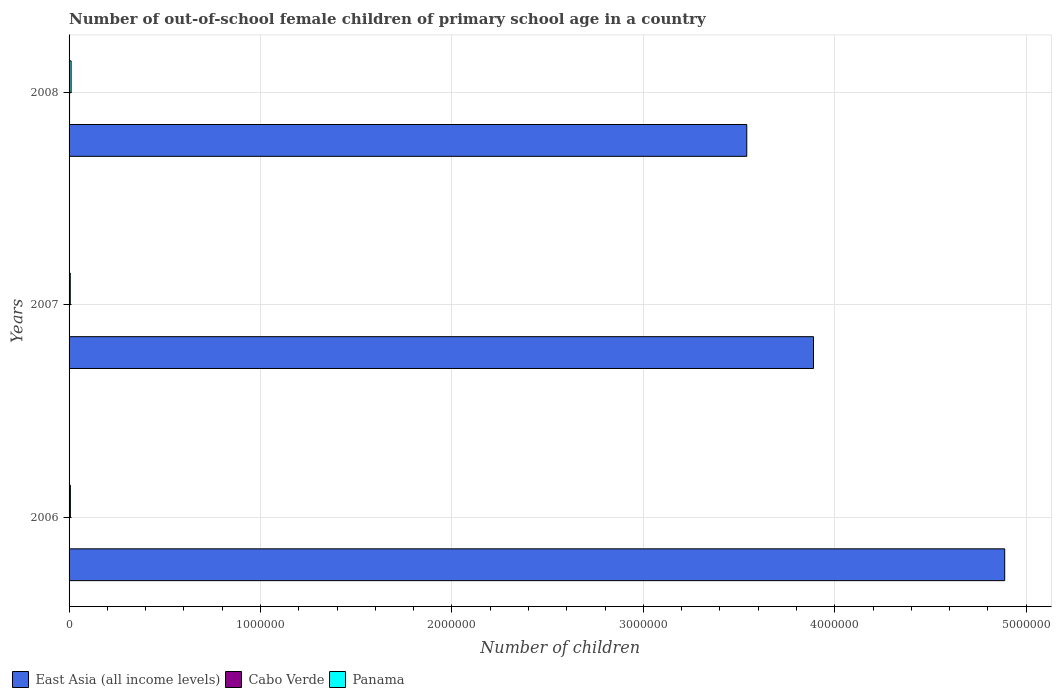How many different coloured bars are there?
Give a very brief answer. 3. Are the number of bars on each tick of the Y-axis equal?
Provide a short and direct response. Yes. How many bars are there on the 2nd tick from the top?
Keep it short and to the point. 3. How many bars are there on the 3rd tick from the bottom?
Provide a short and direct response. 3. What is the label of the 3rd group of bars from the top?
Give a very brief answer. 2006. In how many cases, is the number of bars for a given year not equal to the number of legend labels?
Keep it short and to the point. 0. What is the number of out-of-school female children in East Asia (all income levels) in 2007?
Your response must be concise. 3.89e+06. Across all years, what is the maximum number of out-of-school female children in Panama?
Give a very brief answer. 1.06e+04. Across all years, what is the minimum number of out-of-school female children in East Asia (all income levels)?
Keep it short and to the point. 3.54e+06. In which year was the number of out-of-school female children in East Asia (all income levels) maximum?
Provide a short and direct response. 2006. In which year was the number of out-of-school female children in East Asia (all income levels) minimum?
Provide a succinct answer. 2008. What is the total number of out-of-school female children in Panama in the graph?
Make the answer very short. 2.37e+04. What is the difference between the number of out-of-school female children in Panama in 2006 and that in 2007?
Offer a very short reply. 536. What is the difference between the number of out-of-school female children in Panama in 2008 and the number of out-of-school female children in East Asia (all income levels) in 2007?
Your response must be concise. -3.88e+06. What is the average number of out-of-school female children in Cabo Verde per year?
Provide a short and direct response. 2289. In the year 2006, what is the difference between the number of out-of-school female children in Cabo Verde and number of out-of-school female children in East Asia (all income levels)?
Keep it short and to the point. -4.89e+06. In how many years, is the number of out-of-school female children in Cabo Verde greater than 600000 ?
Keep it short and to the point. 0. What is the ratio of the number of out-of-school female children in Cabo Verde in 2006 to that in 2007?
Give a very brief answer. 0.85. What is the difference between the highest and the second highest number of out-of-school female children in Panama?
Keep it short and to the point. 3836. What is the difference between the highest and the lowest number of out-of-school female children in Panama?
Give a very brief answer. 4372. Is the sum of the number of out-of-school female children in Panama in 2007 and 2008 greater than the maximum number of out-of-school female children in Cabo Verde across all years?
Provide a succinct answer. Yes. What does the 2nd bar from the top in 2006 represents?
Provide a short and direct response. Cabo Verde. What does the 3rd bar from the bottom in 2007 represents?
Offer a very short reply. Panama. Is it the case that in every year, the sum of the number of out-of-school female children in East Asia (all income levels) and number of out-of-school female children in Panama is greater than the number of out-of-school female children in Cabo Verde?
Ensure brevity in your answer.  Yes. How many years are there in the graph?
Keep it short and to the point. 3. Are the values on the major ticks of X-axis written in scientific E-notation?
Give a very brief answer. No. Does the graph contain any zero values?
Your response must be concise. No. Does the graph contain grids?
Offer a terse response. Yes. What is the title of the graph?
Provide a short and direct response. Number of out-of-school female children of primary school age in a country. What is the label or title of the X-axis?
Your response must be concise. Number of children. What is the Number of children of East Asia (all income levels) in 2006?
Your answer should be compact. 4.89e+06. What is the Number of children of Cabo Verde in 2006?
Give a very brief answer. 1975. What is the Number of children in Panama in 2006?
Ensure brevity in your answer.  6809. What is the Number of children in East Asia (all income levels) in 2007?
Provide a short and direct response. 3.89e+06. What is the Number of children in Cabo Verde in 2007?
Offer a very short reply. 2321. What is the Number of children of Panama in 2007?
Give a very brief answer. 6273. What is the Number of children in East Asia (all income levels) in 2008?
Provide a short and direct response. 3.54e+06. What is the Number of children of Cabo Verde in 2008?
Provide a short and direct response. 2571. What is the Number of children in Panama in 2008?
Offer a very short reply. 1.06e+04. Across all years, what is the maximum Number of children in East Asia (all income levels)?
Ensure brevity in your answer.  4.89e+06. Across all years, what is the maximum Number of children of Cabo Verde?
Provide a succinct answer. 2571. Across all years, what is the maximum Number of children of Panama?
Provide a succinct answer. 1.06e+04. Across all years, what is the minimum Number of children of East Asia (all income levels)?
Your answer should be very brief. 3.54e+06. Across all years, what is the minimum Number of children of Cabo Verde?
Offer a very short reply. 1975. Across all years, what is the minimum Number of children of Panama?
Keep it short and to the point. 6273. What is the total Number of children in East Asia (all income levels) in the graph?
Your answer should be very brief. 1.23e+07. What is the total Number of children of Cabo Verde in the graph?
Your answer should be very brief. 6867. What is the total Number of children of Panama in the graph?
Offer a very short reply. 2.37e+04. What is the difference between the Number of children in East Asia (all income levels) in 2006 and that in 2007?
Your answer should be very brief. 9.99e+05. What is the difference between the Number of children in Cabo Verde in 2006 and that in 2007?
Give a very brief answer. -346. What is the difference between the Number of children in Panama in 2006 and that in 2007?
Your response must be concise. 536. What is the difference between the Number of children of East Asia (all income levels) in 2006 and that in 2008?
Provide a succinct answer. 1.35e+06. What is the difference between the Number of children in Cabo Verde in 2006 and that in 2008?
Give a very brief answer. -596. What is the difference between the Number of children in Panama in 2006 and that in 2008?
Your answer should be compact. -3836. What is the difference between the Number of children of East Asia (all income levels) in 2007 and that in 2008?
Provide a succinct answer. 3.49e+05. What is the difference between the Number of children of Cabo Verde in 2007 and that in 2008?
Keep it short and to the point. -250. What is the difference between the Number of children in Panama in 2007 and that in 2008?
Provide a short and direct response. -4372. What is the difference between the Number of children of East Asia (all income levels) in 2006 and the Number of children of Cabo Verde in 2007?
Your answer should be very brief. 4.89e+06. What is the difference between the Number of children of East Asia (all income levels) in 2006 and the Number of children of Panama in 2007?
Provide a succinct answer. 4.88e+06. What is the difference between the Number of children in Cabo Verde in 2006 and the Number of children in Panama in 2007?
Your answer should be compact. -4298. What is the difference between the Number of children in East Asia (all income levels) in 2006 and the Number of children in Cabo Verde in 2008?
Your response must be concise. 4.89e+06. What is the difference between the Number of children of East Asia (all income levels) in 2006 and the Number of children of Panama in 2008?
Offer a terse response. 4.88e+06. What is the difference between the Number of children in Cabo Verde in 2006 and the Number of children in Panama in 2008?
Offer a very short reply. -8670. What is the difference between the Number of children in East Asia (all income levels) in 2007 and the Number of children in Cabo Verde in 2008?
Give a very brief answer. 3.89e+06. What is the difference between the Number of children of East Asia (all income levels) in 2007 and the Number of children of Panama in 2008?
Your answer should be compact. 3.88e+06. What is the difference between the Number of children in Cabo Verde in 2007 and the Number of children in Panama in 2008?
Keep it short and to the point. -8324. What is the average Number of children of East Asia (all income levels) per year?
Make the answer very short. 4.11e+06. What is the average Number of children of Cabo Verde per year?
Keep it short and to the point. 2289. What is the average Number of children in Panama per year?
Offer a terse response. 7909. In the year 2006, what is the difference between the Number of children of East Asia (all income levels) and Number of children of Cabo Verde?
Your response must be concise. 4.89e+06. In the year 2006, what is the difference between the Number of children of East Asia (all income levels) and Number of children of Panama?
Your response must be concise. 4.88e+06. In the year 2006, what is the difference between the Number of children of Cabo Verde and Number of children of Panama?
Offer a terse response. -4834. In the year 2007, what is the difference between the Number of children in East Asia (all income levels) and Number of children in Cabo Verde?
Provide a short and direct response. 3.89e+06. In the year 2007, what is the difference between the Number of children of East Asia (all income levels) and Number of children of Panama?
Offer a very short reply. 3.88e+06. In the year 2007, what is the difference between the Number of children in Cabo Verde and Number of children in Panama?
Make the answer very short. -3952. In the year 2008, what is the difference between the Number of children of East Asia (all income levels) and Number of children of Cabo Verde?
Keep it short and to the point. 3.54e+06. In the year 2008, what is the difference between the Number of children of East Asia (all income levels) and Number of children of Panama?
Give a very brief answer. 3.53e+06. In the year 2008, what is the difference between the Number of children in Cabo Verde and Number of children in Panama?
Give a very brief answer. -8074. What is the ratio of the Number of children in East Asia (all income levels) in 2006 to that in 2007?
Offer a terse response. 1.26. What is the ratio of the Number of children of Cabo Verde in 2006 to that in 2007?
Your answer should be very brief. 0.85. What is the ratio of the Number of children in Panama in 2006 to that in 2007?
Your response must be concise. 1.09. What is the ratio of the Number of children of East Asia (all income levels) in 2006 to that in 2008?
Provide a succinct answer. 1.38. What is the ratio of the Number of children in Cabo Verde in 2006 to that in 2008?
Provide a succinct answer. 0.77. What is the ratio of the Number of children of Panama in 2006 to that in 2008?
Give a very brief answer. 0.64. What is the ratio of the Number of children in East Asia (all income levels) in 2007 to that in 2008?
Make the answer very short. 1.1. What is the ratio of the Number of children in Cabo Verde in 2007 to that in 2008?
Your answer should be very brief. 0.9. What is the ratio of the Number of children of Panama in 2007 to that in 2008?
Ensure brevity in your answer.  0.59. What is the difference between the highest and the second highest Number of children in East Asia (all income levels)?
Provide a short and direct response. 9.99e+05. What is the difference between the highest and the second highest Number of children of Cabo Verde?
Make the answer very short. 250. What is the difference between the highest and the second highest Number of children in Panama?
Give a very brief answer. 3836. What is the difference between the highest and the lowest Number of children in East Asia (all income levels)?
Give a very brief answer. 1.35e+06. What is the difference between the highest and the lowest Number of children of Cabo Verde?
Offer a terse response. 596. What is the difference between the highest and the lowest Number of children of Panama?
Provide a succinct answer. 4372. 